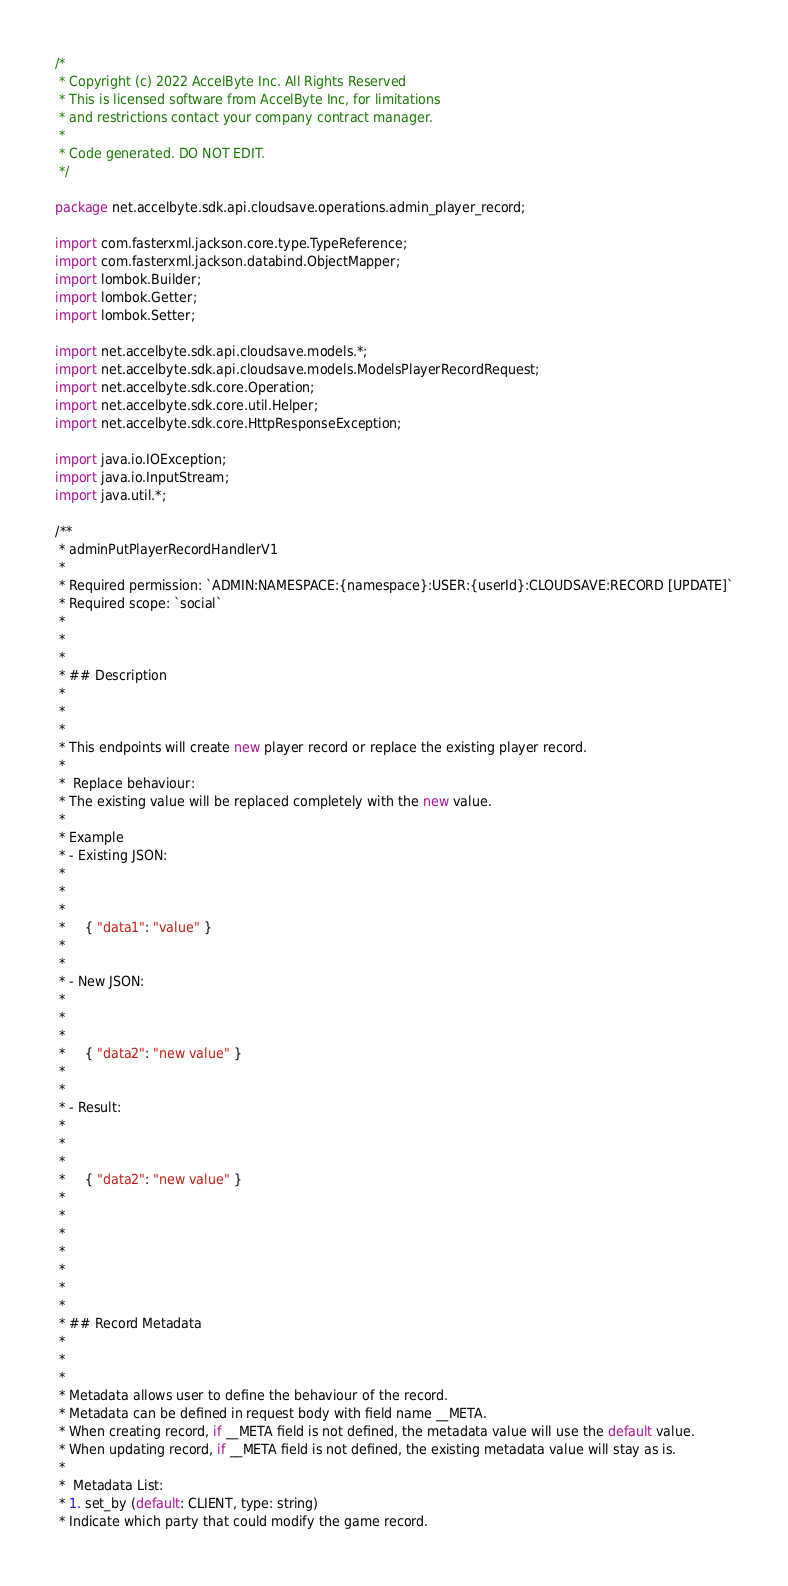Convert code to text. <code><loc_0><loc_0><loc_500><loc_500><_Java_>/*
 * Copyright (c) 2022 AccelByte Inc. All Rights Reserved
 * This is licensed software from AccelByte Inc, for limitations
 * and restrictions contact your company contract manager.
 *
 * Code generated. DO NOT EDIT.
 */

package net.accelbyte.sdk.api.cloudsave.operations.admin_player_record;

import com.fasterxml.jackson.core.type.TypeReference;
import com.fasterxml.jackson.databind.ObjectMapper;
import lombok.Builder;
import lombok.Getter;
import lombok.Setter;

import net.accelbyte.sdk.api.cloudsave.models.*;
import net.accelbyte.sdk.api.cloudsave.models.ModelsPlayerRecordRequest;
import net.accelbyte.sdk.core.Operation;
import net.accelbyte.sdk.core.util.Helper;
import net.accelbyte.sdk.core.HttpResponseException;

import java.io.IOException;
import java.io.InputStream;
import java.util.*;

/**
 * adminPutPlayerRecordHandlerV1
 *
 * Required permission: `ADMIN:NAMESPACE:{namespace}:USER:{userId}:CLOUDSAVE:RECORD [UPDATE]`
 * Required scope: `social`
 * 
 * 
 * 
 * ## Description
 * 
 * 
 * 
 * This endpoints will create new player record or replace the existing player record.
 * 
 *  Replace behaviour:
 * The existing value will be replaced completely with the new value.
 * 
 * Example
 * - Existing JSON:
 * 
 * 
 * 
 *     { "data1": "value" }
 * 
 * 
 * - New JSON:
 * 
 * 
 * 
 *     { "data2": "new value" }
 * 
 * 
 * - Result:
 * 
 * 
 * 
 *     { "data2": "new value" }
 * 
 * 
 * 
 * 
 * 
 * 
 * 
 * ## Record Metadata
 * 
 * 
 * 
 * Metadata allows user to define the behaviour of the record.
 * Metadata can be defined in request body with field name __META.
 * When creating record, if __META field is not defined, the metadata value will use the default value.
 * When updating record, if __META field is not defined, the existing metadata value will stay as is.
 * 
 *  Metadata List:
 * 1. set_by (default: CLIENT, type: string)
 * Indicate which party that could modify the game record.</code> 